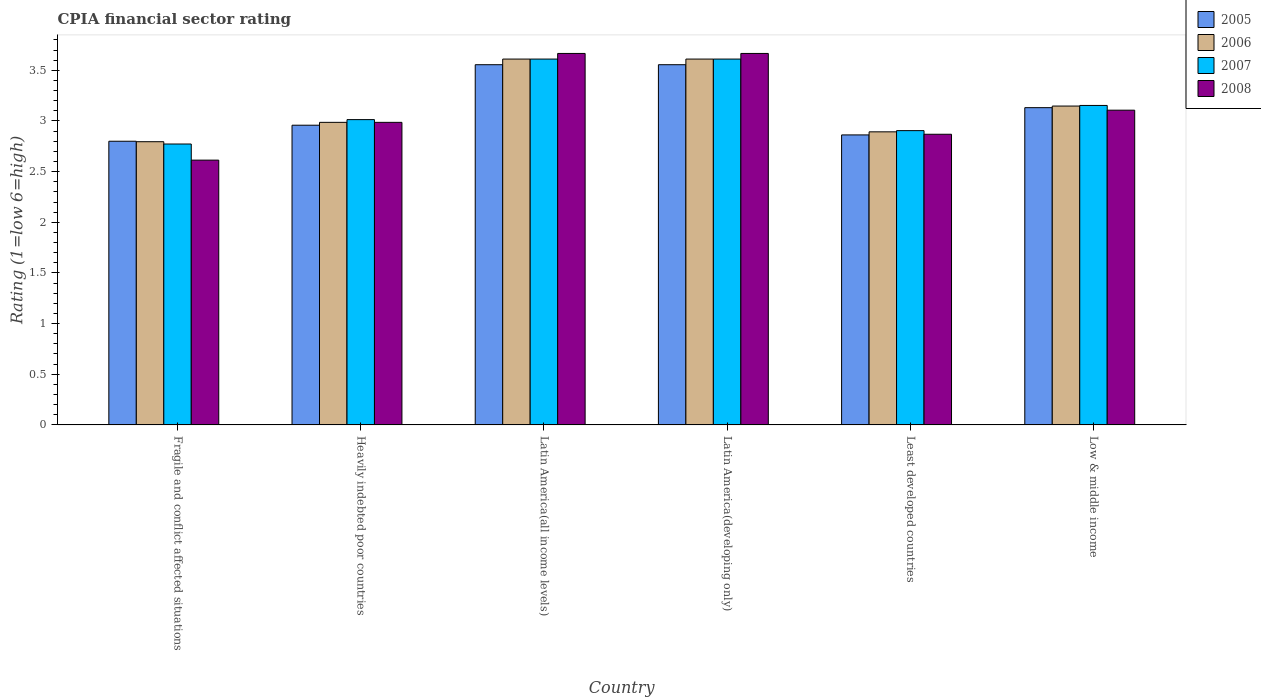How many different coloured bars are there?
Ensure brevity in your answer.  4. How many groups of bars are there?
Offer a very short reply. 6. Are the number of bars per tick equal to the number of legend labels?
Ensure brevity in your answer.  Yes. How many bars are there on the 2nd tick from the right?
Provide a short and direct response. 4. What is the label of the 1st group of bars from the left?
Give a very brief answer. Fragile and conflict affected situations. In how many cases, is the number of bars for a given country not equal to the number of legend labels?
Provide a succinct answer. 0. What is the CPIA rating in 2005 in Least developed countries?
Your response must be concise. 2.86. Across all countries, what is the maximum CPIA rating in 2006?
Give a very brief answer. 3.61. In which country was the CPIA rating in 2008 maximum?
Keep it short and to the point. Latin America(all income levels). In which country was the CPIA rating in 2005 minimum?
Keep it short and to the point. Fragile and conflict affected situations. What is the total CPIA rating in 2005 in the graph?
Your answer should be compact. 18.86. What is the difference between the CPIA rating in 2007 in Latin America(developing only) and that in Low & middle income?
Make the answer very short. 0.46. What is the difference between the CPIA rating in 2006 in Latin America(developing only) and the CPIA rating in 2005 in Fragile and conflict affected situations?
Provide a succinct answer. 0.81. What is the average CPIA rating in 2005 per country?
Your answer should be very brief. 3.14. What is the ratio of the CPIA rating in 2005 in Heavily indebted poor countries to that in Latin America(all income levels)?
Provide a succinct answer. 0.83. Is the CPIA rating in 2005 in Least developed countries less than that in Low & middle income?
Provide a short and direct response. Yes. What is the difference between the highest and the second highest CPIA rating in 2005?
Provide a succinct answer. -0.42. What is the difference between the highest and the lowest CPIA rating in 2006?
Ensure brevity in your answer.  0.82. In how many countries, is the CPIA rating in 2006 greater than the average CPIA rating in 2006 taken over all countries?
Make the answer very short. 2. Is the sum of the CPIA rating in 2008 in Heavily indebted poor countries and Latin America(developing only) greater than the maximum CPIA rating in 2006 across all countries?
Your answer should be compact. Yes. What does the 4th bar from the left in Heavily indebted poor countries represents?
Keep it short and to the point. 2008. What does the 2nd bar from the right in Heavily indebted poor countries represents?
Provide a succinct answer. 2007. How many countries are there in the graph?
Offer a terse response. 6. What is the difference between two consecutive major ticks on the Y-axis?
Your answer should be compact. 0.5. Are the values on the major ticks of Y-axis written in scientific E-notation?
Offer a very short reply. No. Does the graph contain grids?
Your answer should be very brief. No. How many legend labels are there?
Your answer should be compact. 4. What is the title of the graph?
Ensure brevity in your answer.  CPIA financial sector rating. Does "2013" appear as one of the legend labels in the graph?
Keep it short and to the point. No. What is the label or title of the X-axis?
Give a very brief answer. Country. What is the label or title of the Y-axis?
Provide a succinct answer. Rating (1=low 6=high). What is the Rating (1=low 6=high) of 2005 in Fragile and conflict affected situations?
Your answer should be very brief. 2.8. What is the Rating (1=low 6=high) in 2006 in Fragile and conflict affected situations?
Offer a terse response. 2.8. What is the Rating (1=low 6=high) of 2007 in Fragile and conflict affected situations?
Offer a terse response. 2.77. What is the Rating (1=low 6=high) of 2008 in Fragile and conflict affected situations?
Give a very brief answer. 2.61. What is the Rating (1=low 6=high) of 2005 in Heavily indebted poor countries?
Give a very brief answer. 2.96. What is the Rating (1=low 6=high) in 2006 in Heavily indebted poor countries?
Your answer should be very brief. 2.99. What is the Rating (1=low 6=high) in 2007 in Heavily indebted poor countries?
Your answer should be compact. 3.01. What is the Rating (1=low 6=high) of 2008 in Heavily indebted poor countries?
Your answer should be compact. 2.99. What is the Rating (1=low 6=high) of 2005 in Latin America(all income levels)?
Your response must be concise. 3.56. What is the Rating (1=low 6=high) in 2006 in Latin America(all income levels)?
Ensure brevity in your answer.  3.61. What is the Rating (1=low 6=high) in 2007 in Latin America(all income levels)?
Offer a terse response. 3.61. What is the Rating (1=low 6=high) of 2008 in Latin America(all income levels)?
Your response must be concise. 3.67. What is the Rating (1=low 6=high) in 2005 in Latin America(developing only)?
Offer a terse response. 3.56. What is the Rating (1=low 6=high) of 2006 in Latin America(developing only)?
Make the answer very short. 3.61. What is the Rating (1=low 6=high) in 2007 in Latin America(developing only)?
Your answer should be compact. 3.61. What is the Rating (1=low 6=high) in 2008 in Latin America(developing only)?
Offer a terse response. 3.67. What is the Rating (1=low 6=high) in 2005 in Least developed countries?
Your answer should be very brief. 2.86. What is the Rating (1=low 6=high) of 2006 in Least developed countries?
Offer a very short reply. 2.89. What is the Rating (1=low 6=high) in 2007 in Least developed countries?
Keep it short and to the point. 2.9. What is the Rating (1=low 6=high) in 2008 in Least developed countries?
Your response must be concise. 2.87. What is the Rating (1=low 6=high) of 2005 in Low & middle income?
Your answer should be compact. 3.13. What is the Rating (1=low 6=high) of 2006 in Low & middle income?
Offer a very short reply. 3.15. What is the Rating (1=low 6=high) in 2007 in Low & middle income?
Offer a very short reply. 3.15. What is the Rating (1=low 6=high) in 2008 in Low & middle income?
Make the answer very short. 3.11. Across all countries, what is the maximum Rating (1=low 6=high) of 2005?
Offer a terse response. 3.56. Across all countries, what is the maximum Rating (1=low 6=high) in 2006?
Give a very brief answer. 3.61. Across all countries, what is the maximum Rating (1=low 6=high) in 2007?
Your response must be concise. 3.61. Across all countries, what is the maximum Rating (1=low 6=high) of 2008?
Give a very brief answer. 3.67. Across all countries, what is the minimum Rating (1=low 6=high) of 2005?
Keep it short and to the point. 2.8. Across all countries, what is the minimum Rating (1=low 6=high) in 2006?
Ensure brevity in your answer.  2.8. Across all countries, what is the minimum Rating (1=low 6=high) in 2007?
Offer a terse response. 2.77. Across all countries, what is the minimum Rating (1=low 6=high) in 2008?
Provide a succinct answer. 2.61. What is the total Rating (1=low 6=high) in 2005 in the graph?
Ensure brevity in your answer.  18.86. What is the total Rating (1=low 6=high) in 2006 in the graph?
Provide a succinct answer. 19.04. What is the total Rating (1=low 6=high) of 2007 in the graph?
Your response must be concise. 19.07. What is the total Rating (1=low 6=high) of 2008 in the graph?
Provide a short and direct response. 18.91. What is the difference between the Rating (1=low 6=high) in 2005 in Fragile and conflict affected situations and that in Heavily indebted poor countries?
Make the answer very short. -0.16. What is the difference between the Rating (1=low 6=high) of 2006 in Fragile and conflict affected situations and that in Heavily indebted poor countries?
Offer a terse response. -0.19. What is the difference between the Rating (1=low 6=high) of 2007 in Fragile and conflict affected situations and that in Heavily indebted poor countries?
Make the answer very short. -0.24. What is the difference between the Rating (1=low 6=high) of 2008 in Fragile and conflict affected situations and that in Heavily indebted poor countries?
Provide a succinct answer. -0.37. What is the difference between the Rating (1=low 6=high) of 2005 in Fragile and conflict affected situations and that in Latin America(all income levels)?
Offer a very short reply. -0.76. What is the difference between the Rating (1=low 6=high) in 2006 in Fragile and conflict affected situations and that in Latin America(all income levels)?
Your answer should be very brief. -0.82. What is the difference between the Rating (1=low 6=high) in 2007 in Fragile and conflict affected situations and that in Latin America(all income levels)?
Provide a succinct answer. -0.84. What is the difference between the Rating (1=low 6=high) in 2008 in Fragile and conflict affected situations and that in Latin America(all income levels)?
Ensure brevity in your answer.  -1.05. What is the difference between the Rating (1=low 6=high) in 2005 in Fragile and conflict affected situations and that in Latin America(developing only)?
Offer a terse response. -0.76. What is the difference between the Rating (1=low 6=high) in 2006 in Fragile and conflict affected situations and that in Latin America(developing only)?
Keep it short and to the point. -0.82. What is the difference between the Rating (1=low 6=high) in 2007 in Fragile and conflict affected situations and that in Latin America(developing only)?
Your answer should be compact. -0.84. What is the difference between the Rating (1=low 6=high) of 2008 in Fragile and conflict affected situations and that in Latin America(developing only)?
Provide a short and direct response. -1.05. What is the difference between the Rating (1=low 6=high) of 2005 in Fragile and conflict affected situations and that in Least developed countries?
Offer a terse response. -0.06. What is the difference between the Rating (1=low 6=high) in 2006 in Fragile and conflict affected situations and that in Least developed countries?
Provide a short and direct response. -0.1. What is the difference between the Rating (1=low 6=high) of 2007 in Fragile and conflict affected situations and that in Least developed countries?
Make the answer very short. -0.13. What is the difference between the Rating (1=low 6=high) in 2008 in Fragile and conflict affected situations and that in Least developed countries?
Offer a very short reply. -0.26. What is the difference between the Rating (1=low 6=high) in 2005 in Fragile and conflict affected situations and that in Low & middle income?
Your response must be concise. -0.33. What is the difference between the Rating (1=low 6=high) in 2006 in Fragile and conflict affected situations and that in Low & middle income?
Provide a succinct answer. -0.35. What is the difference between the Rating (1=low 6=high) in 2007 in Fragile and conflict affected situations and that in Low & middle income?
Ensure brevity in your answer.  -0.38. What is the difference between the Rating (1=low 6=high) of 2008 in Fragile and conflict affected situations and that in Low & middle income?
Keep it short and to the point. -0.49. What is the difference between the Rating (1=low 6=high) in 2005 in Heavily indebted poor countries and that in Latin America(all income levels)?
Offer a very short reply. -0.6. What is the difference between the Rating (1=low 6=high) in 2006 in Heavily indebted poor countries and that in Latin America(all income levels)?
Offer a terse response. -0.62. What is the difference between the Rating (1=low 6=high) of 2007 in Heavily indebted poor countries and that in Latin America(all income levels)?
Offer a very short reply. -0.6. What is the difference between the Rating (1=low 6=high) in 2008 in Heavily indebted poor countries and that in Latin America(all income levels)?
Provide a short and direct response. -0.68. What is the difference between the Rating (1=low 6=high) in 2005 in Heavily indebted poor countries and that in Latin America(developing only)?
Ensure brevity in your answer.  -0.6. What is the difference between the Rating (1=low 6=high) in 2006 in Heavily indebted poor countries and that in Latin America(developing only)?
Provide a succinct answer. -0.62. What is the difference between the Rating (1=low 6=high) of 2007 in Heavily indebted poor countries and that in Latin America(developing only)?
Offer a terse response. -0.6. What is the difference between the Rating (1=low 6=high) in 2008 in Heavily indebted poor countries and that in Latin America(developing only)?
Provide a short and direct response. -0.68. What is the difference between the Rating (1=low 6=high) in 2005 in Heavily indebted poor countries and that in Least developed countries?
Your answer should be very brief. 0.1. What is the difference between the Rating (1=low 6=high) of 2006 in Heavily indebted poor countries and that in Least developed countries?
Offer a terse response. 0.09. What is the difference between the Rating (1=low 6=high) of 2007 in Heavily indebted poor countries and that in Least developed countries?
Keep it short and to the point. 0.11. What is the difference between the Rating (1=low 6=high) in 2008 in Heavily indebted poor countries and that in Least developed countries?
Keep it short and to the point. 0.12. What is the difference between the Rating (1=low 6=high) of 2005 in Heavily indebted poor countries and that in Low & middle income?
Give a very brief answer. -0.17. What is the difference between the Rating (1=low 6=high) in 2006 in Heavily indebted poor countries and that in Low & middle income?
Your answer should be very brief. -0.16. What is the difference between the Rating (1=low 6=high) of 2007 in Heavily indebted poor countries and that in Low & middle income?
Provide a short and direct response. -0.14. What is the difference between the Rating (1=low 6=high) in 2008 in Heavily indebted poor countries and that in Low & middle income?
Provide a succinct answer. -0.12. What is the difference between the Rating (1=low 6=high) in 2005 in Latin America(all income levels) and that in Latin America(developing only)?
Make the answer very short. 0. What is the difference between the Rating (1=low 6=high) in 2007 in Latin America(all income levels) and that in Latin America(developing only)?
Offer a very short reply. 0. What is the difference between the Rating (1=low 6=high) in 2005 in Latin America(all income levels) and that in Least developed countries?
Provide a short and direct response. 0.69. What is the difference between the Rating (1=low 6=high) in 2006 in Latin America(all income levels) and that in Least developed countries?
Your answer should be very brief. 0.72. What is the difference between the Rating (1=low 6=high) in 2007 in Latin America(all income levels) and that in Least developed countries?
Give a very brief answer. 0.71. What is the difference between the Rating (1=low 6=high) of 2008 in Latin America(all income levels) and that in Least developed countries?
Ensure brevity in your answer.  0.8. What is the difference between the Rating (1=low 6=high) in 2005 in Latin America(all income levels) and that in Low & middle income?
Keep it short and to the point. 0.42. What is the difference between the Rating (1=low 6=high) in 2006 in Latin America(all income levels) and that in Low & middle income?
Make the answer very short. 0.46. What is the difference between the Rating (1=low 6=high) in 2007 in Latin America(all income levels) and that in Low & middle income?
Ensure brevity in your answer.  0.46. What is the difference between the Rating (1=low 6=high) of 2008 in Latin America(all income levels) and that in Low & middle income?
Provide a succinct answer. 0.56. What is the difference between the Rating (1=low 6=high) of 2005 in Latin America(developing only) and that in Least developed countries?
Offer a very short reply. 0.69. What is the difference between the Rating (1=low 6=high) in 2006 in Latin America(developing only) and that in Least developed countries?
Give a very brief answer. 0.72. What is the difference between the Rating (1=low 6=high) of 2007 in Latin America(developing only) and that in Least developed countries?
Offer a very short reply. 0.71. What is the difference between the Rating (1=low 6=high) of 2008 in Latin America(developing only) and that in Least developed countries?
Ensure brevity in your answer.  0.8. What is the difference between the Rating (1=low 6=high) of 2005 in Latin America(developing only) and that in Low & middle income?
Offer a very short reply. 0.42. What is the difference between the Rating (1=low 6=high) in 2006 in Latin America(developing only) and that in Low & middle income?
Your response must be concise. 0.46. What is the difference between the Rating (1=low 6=high) of 2007 in Latin America(developing only) and that in Low & middle income?
Your answer should be compact. 0.46. What is the difference between the Rating (1=low 6=high) in 2008 in Latin America(developing only) and that in Low & middle income?
Provide a short and direct response. 0.56. What is the difference between the Rating (1=low 6=high) in 2005 in Least developed countries and that in Low & middle income?
Ensure brevity in your answer.  -0.27. What is the difference between the Rating (1=low 6=high) in 2006 in Least developed countries and that in Low & middle income?
Give a very brief answer. -0.25. What is the difference between the Rating (1=low 6=high) of 2007 in Least developed countries and that in Low & middle income?
Make the answer very short. -0.25. What is the difference between the Rating (1=low 6=high) of 2008 in Least developed countries and that in Low & middle income?
Give a very brief answer. -0.24. What is the difference between the Rating (1=low 6=high) of 2005 in Fragile and conflict affected situations and the Rating (1=low 6=high) of 2006 in Heavily indebted poor countries?
Ensure brevity in your answer.  -0.19. What is the difference between the Rating (1=low 6=high) in 2005 in Fragile and conflict affected situations and the Rating (1=low 6=high) in 2007 in Heavily indebted poor countries?
Ensure brevity in your answer.  -0.21. What is the difference between the Rating (1=low 6=high) of 2005 in Fragile and conflict affected situations and the Rating (1=low 6=high) of 2008 in Heavily indebted poor countries?
Provide a succinct answer. -0.19. What is the difference between the Rating (1=low 6=high) in 2006 in Fragile and conflict affected situations and the Rating (1=low 6=high) in 2007 in Heavily indebted poor countries?
Offer a terse response. -0.22. What is the difference between the Rating (1=low 6=high) in 2006 in Fragile and conflict affected situations and the Rating (1=low 6=high) in 2008 in Heavily indebted poor countries?
Offer a very short reply. -0.19. What is the difference between the Rating (1=low 6=high) of 2007 in Fragile and conflict affected situations and the Rating (1=low 6=high) of 2008 in Heavily indebted poor countries?
Provide a short and direct response. -0.21. What is the difference between the Rating (1=low 6=high) in 2005 in Fragile and conflict affected situations and the Rating (1=low 6=high) in 2006 in Latin America(all income levels)?
Keep it short and to the point. -0.81. What is the difference between the Rating (1=low 6=high) in 2005 in Fragile and conflict affected situations and the Rating (1=low 6=high) in 2007 in Latin America(all income levels)?
Give a very brief answer. -0.81. What is the difference between the Rating (1=low 6=high) of 2005 in Fragile and conflict affected situations and the Rating (1=low 6=high) of 2008 in Latin America(all income levels)?
Offer a very short reply. -0.87. What is the difference between the Rating (1=low 6=high) in 2006 in Fragile and conflict affected situations and the Rating (1=low 6=high) in 2007 in Latin America(all income levels)?
Offer a very short reply. -0.82. What is the difference between the Rating (1=low 6=high) of 2006 in Fragile and conflict affected situations and the Rating (1=low 6=high) of 2008 in Latin America(all income levels)?
Keep it short and to the point. -0.87. What is the difference between the Rating (1=low 6=high) of 2007 in Fragile and conflict affected situations and the Rating (1=low 6=high) of 2008 in Latin America(all income levels)?
Make the answer very short. -0.89. What is the difference between the Rating (1=low 6=high) in 2005 in Fragile and conflict affected situations and the Rating (1=low 6=high) in 2006 in Latin America(developing only)?
Ensure brevity in your answer.  -0.81. What is the difference between the Rating (1=low 6=high) of 2005 in Fragile and conflict affected situations and the Rating (1=low 6=high) of 2007 in Latin America(developing only)?
Your answer should be very brief. -0.81. What is the difference between the Rating (1=low 6=high) in 2005 in Fragile and conflict affected situations and the Rating (1=low 6=high) in 2008 in Latin America(developing only)?
Make the answer very short. -0.87. What is the difference between the Rating (1=low 6=high) of 2006 in Fragile and conflict affected situations and the Rating (1=low 6=high) of 2007 in Latin America(developing only)?
Provide a short and direct response. -0.82. What is the difference between the Rating (1=low 6=high) of 2006 in Fragile and conflict affected situations and the Rating (1=low 6=high) of 2008 in Latin America(developing only)?
Your response must be concise. -0.87. What is the difference between the Rating (1=low 6=high) of 2007 in Fragile and conflict affected situations and the Rating (1=low 6=high) of 2008 in Latin America(developing only)?
Offer a terse response. -0.89. What is the difference between the Rating (1=low 6=high) of 2005 in Fragile and conflict affected situations and the Rating (1=low 6=high) of 2006 in Least developed countries?
Offer a terse response. -0.09. What is the difference between the Rating (1=low 6=high) in 2005 in Fragile and conflict affected situations and the Rating (1=low 6=high) in 2007 in Least developed countries?
Keep it short and to the point. -0.1. What is the difference between the Rating (1=low 6=high) of 2005 in Fragile and conflict affected situations and the Rating (1=low 6=high) of 2008 in Least developed countries?
Your answer should be compact. -0.07. What is the difference between the Rating (1=low 6=high) of 2006 in Fragile and conflict affected situations and the Rating (1=low 6=high) of 2007 in Least developed countries?
Your response must be concise. -0.11. What is the difference between the Rating (1=low 6=high) of 2006 in Fragile and conflict affected situations and the Rating (1=low 6=high) of 2008 in Least developed countries?
Your answer should be very brief. -0.07. What is the difference between the Rating (1=low 6=high) in 2007 in Fragile and conflict affected situations and the Rating (1=low 6=high) in 2008 in Least developed countries?
Offer a very short reply. -0.1. What is the difference between the Rating (1=low 6=high) of 2005 in Fragile and conflict affected situations and the Rating (1=low 6=high) of 2006 in Low & middle income?
Your answer should be very brief. -0.35. What is the difference between the Rating (1=low 6=high) in 2005 in Fragile and conflict affected situations and the Rating (1=low 6=high) in 2007 in Low & middle income?
Offer a terse response. -0.35. What is the difference between the Rating (1=low 6=high) in 2005 in Fragile and conflict affected situations and the Rating (1=low 6=high) in 2008 in Low & middle income?
Give a very brief answer. -0.31. What is the difference between the Rating (1=low 6=high) of 2006 in Fragile and conflict affected situations and the Rating (1=low 6=high) of 2007 in Low & middle income?
Offer a very short reply. -0.36. What is the difference between the Rating (1=low 6=high) in 2006 in Fragile and conflict affected situations and the Rating (1=low 6=high) in 2008 in Low & middle income?
Make the answer very short. -0.31. What is the difference between the Rating (1=low 6=high) of 2007 in Fragile and conflict affected situations and the Rating (1=low 6=high) of 2008 in Low & middle income?
Provide a short and direct response. -0.33. What is the difference between the Rating (1=low 6=high) in 2005 in Heavily indebted poor countries and the Rating (1=low 6=high) in 2006 in Latin America(all income levels)?
Your response must be concise. -0.65. What is the difference between the Rating (1=low 6=high) of 2005 in Heavily indebted poor countries and the Rating (1=low 6=high) of 2007 in Latin America(all income levels)?
Provide a succinct answer. -0.65. What is the difference between the Rating (1=low 6=high) in 2005 in Heavily indebted poor countries and the Rating (1=low 6=high) in 2008 in Latin America(all income levels)?
Your answer should be very brief. -0.71. What is the difference between the Rating (1=low 6=high) in 2006 in Heavily indebted poor countries and the Rating (1=low 6=high) in 2007 in Latin America(all income levels)?
Offer a very short reply. -0.62. What is the difference between the Rating (1=low 6=high) in 2006 in Heavily indebted poor countries and the Rating (1=low 6=high) in 2008 in Latin America(all income levels)?
Your response must be concise. -0.68. What is the difference between the Rating (1=low 6=high) in 2007 in Heavily indebted poor countries and the Rating (1=low 6=high) in 2008 in Latin America(all income levels)?
Give a very brief answer. -0.65. What is the difference between the Rating (1=low 6=high) of 2005 in Heavily indebted poor countries and the Rating (1=low 6=high) of 2006 in Latin America(developing only)?
Offer a very short reply. -0.65. What is the difference between the Rating (1=low 6=high) of 2005 in Heavily indebted poor countries and the Rating (1=low 6=high) of 2007 in Latin America(developing only)?
Ensure brevity in your answer.  -0.65. What is the difference between the Rating (1=low 6=high) of 2005 in Heavily indebted poor countries and the Rating (1=low 6=high) of 2008 in Latin America(developing only)?
Keep it short and to the point. -0.71. What is the difference between the Rating (1=low 6=high) in 2006 in Heavily indebted poor countries and the Rating (1=low 6=high) in 2007 in Latin America(developing only)?
Provide a short and direct response. -0.62. What is the difference between the Rating (1=low 6=high) of 2006 in Heavily indebted poor countries and the Rating (1=low 6=high) of 2008 in Latin America(developing only)?
Keep it short and to the point. -0.68. What is the difference between the Rating (1=low 6=high) in 2007 in Heavily indebted poor countries and the Rating (1=low 6=high) in 2008 in Latin America(developing only)?
Ensure brevity in your answer.  -0.65. What is the difference between the Rating (1=low 6=high) of 2005 in Heavily indebted poor countries and the Rating (1=low 6=high) of 2006 in Least developed countries?
Your answer should be compact. 0.07. What is the difference between the Rating (1=low 6=high) of 2005 in Heavily indebted poor countries and the Rating (1=low 6=high) of 2007 in Least developed countries?
Ensure brevity in your answer.  0.05. What is the difference between the Rating (1=low 6=high) in 2005 in Heavily indebted poor countries and the Rating (1=low 6=high) in 2008 in Least developed countries?
Provide a short and direct response. 0.09. What is the difference between the Rating (1=low 6=high) in 2006 in Heavily indebted poor countries and the Rating (1=low 6=high) in 2007 in Least developed countries?
Your answer should be very brief. 0.08. What is the difference between the Rating (1=low 6=high) in 2006 in Heavily indebted poor countries and the Rating (1=low 6=high) in 2008 in Least developed countries?
Offer a terse response. 0.12. What is the difference between the Rating (1=low 6=high) in 2007 in Heavily indebted poor countries and the Rating (1=low 6=high) in 2008 in Least developed countries?
Provide a short and direct response. 0.14. What is the difference between the Rating (1=low 6=high) of 2005 in Heavily indebted poor countries and the Rating (1=low 6=high) of 2006 in Low & middle income?
Your answer should be compact. -0.19. What is the difference between the Rating (1=low 6=high) in 2005 in Heavily indebted poor countries and the Rating (1=low 6=high) in 2007 in Low & middle income?
Your response must be concise. -0.2. What is the difference between the Rating (1=low 6=high) in 2005 in Heavily indebted poor countries and the Rating (1=low 6=high) in 2008 in Low & middle income?
Your answer should be very brief. -0.15. What is the difference between the Rating (1=low 6=high) of 2006 in Heavily indebted poor countries and the Rating (1=low 6=high) of 2007 in Low & middle income?
Keep it short and to the point. -0.17. What is the difference between the Rating (1=low 6=high) in 2006 in Heavily indebted poor countries and the Rating (1=low 6=high) in 2008 in Low & middle income?
Your answer should be compact. -0.12. What is the difference between the Rating (1=low 6=high) in 2007 in Heavily indebted poor countries and the Rating (1=low 6=high) in 2008 in Low & middle income?
Provide a succinct answer. -0.09. What is the difference between the Rating (1=low 6=high) of 2005 in Latin America(all income levels) and the Rating (1=low 6=high) of 2006 in Latin America(developing only)?
Your response must be concise. -0.06. What is the difference between the Rating (1=low 6=high) in 2005 in Latin America(all income levels) and the Rating (1=low 6=high) in 2007 in Latin America(developing only)?
Your response must be concise. -0.06. What is the difference between the Rating (1=low 6=high) in 2005 in Latin America(all income levels) and the Rating (1=low 6=high) in 2008 in Latin America(developing only)?
Ensure brevity in your answer.  -0.11. What is the difference between the Rating (1=low 6=high) in 2006 in Latin America(all income levels) and the Rating (1=low 6=high) in 2008 in Latin America(developing only)?
Make the answer very short. -0.06. What is the difference between the Rating (1=low 6=high) in 2007 in Latin America(all income levels) and the Rating (1=low 6=high) in 2008 in Latin America(developing only)?
Make the answer very short. -0.06. What is the difference between the Rating (1=low 6=high) in 2005 in Latin America(all income levels) and the Rating (1=low 6=high) in 2006 in Least developed countries?
Your answer should be compact. 0.66. What is the difference between the Rating (1=low 6=high) of 2005 in Latin America(all income levels) and the Rating (1=low 6=high) of 2007 in Least developed countries?
Keep it short and to the point. 0.65. What is the difference between the Rating (1=low 6=high) in 2005 in Latin America(all income levels) and the Rating (1=low 6=high) in 2008 in Least developed countries?
Keep it short and to the point. 0.69. What is the difference between the Rating (1=low 6=high) of 2006 in Latin America(all income levels) and the Rating (1=low 6=high) of 2007 in Least developed countries?
Keep it short and to the point. 0.71. What is the difference between the Rating (1=low 6=high) in 2006 in Latin America(all income levels) and the Rating (1=low 6=high) in 2008 in Least developed countries?
Ensure brevity in your answer.  0.74. What is the difference between the Rating (1=low 6=high) in 2007 in Latin America(all income levels) and the Rating (1=low 6=high) in 2008 in Least developed countries?
Give a very brief answer. 0.74. What is the difference between the Rating (1=low 6=high) in 2005 in Latin America(all income levels) and the Rating (1=low 6=high) in 2006 in Low & middle income?
Offer a terse response. 0.41. What is the difference between the Rating (1=low 6=high) of 2005 in Latin America(all income levels) and the Rating (1=low 6=high) of 2007 in Low & middle income?
Offer a very short reply. 0.4. What is the difference between the Rating (1=low 6=high) of 2005 in Latin America(all income levels) and the Rating (1=low 6=high) of 2008 in Low & middle income?
Offer a very short reply. 0.45. What is the difference between the Rating (1=low 6=high) in 2006 in Latin America(all income levels) and the Rating (1=low 6=high) in 2007 in Low & middle income?
Ensure brevity in your answer.  0.46. What is the difference between the Rating (1=low 6=high) in 2006 in Latin America(all income levels) and the Rating (1=low 6=high) in 2008 in Low & middle income?
Ensure brevity in your answer.  0.5. What is the difference between the Rating (1=low 6=high) in 2007 in Latin America(all income levels) and the Rating (1=low 6=high) in 2008 in Low & middle income?
Offer a very short reply. 0.5. What is the difference between the Rating (1=low 6=high) in 2005 in Latin America(developing only) and the Rating (1=low 6=high) in 2006 in Least developed countries?
Offer a very short reply. 0.66. What is the difference between the Rating (1=low 6=high) in 2005 in Latin America(developing only) and the Rating (1=low 6=high) in 2007 in Least developed countries?
Your answer should be compact. 0.65. What is the difference between the Rating (1=low 6=high) in 2005 in Latin America(developing only) and the Rating (1=low 6=high) in 2008 in Least developed countries?
Give a very brief answer. 0.69. What is the difference between the Rating (1=low 6=high) in 2006 in Latin America(developing only) and the Rating (1=low 6=high) in 2007 in Least developed countries?
Offer a terse response. 0.71. What is the difference between the Rating (1=low 6=high) of 2006 in Latin America(developing only) and the Rating (1=low 6=high) of 2008 in Least developed countries?
Offer a very short reply. 0.74. What is the difference between the Rating (1=low 6=high) of 2007 in Latin America(developing only) and the Rating (1=low 6=high) of 2008 in Least developed countries?
Make the answer very short. 0.74. What is the difference between the Rating (1=low 6=high) in 2005 in Latin America(developing only) and the Rating (1=low 6=high) in 2006 in Low & middle income?
Ensure brevity in your answer.  0.41. What is the difference between the Rating (1=low 6=high) in 2005 in Latin America(developing only) and the Rating (1=low 6=high) in 2007 in Low & middle income?
Keep it short and to the point. 0.4. What is the difference between the Rating (1=low 6=high) of 2005 in Latin America(developing only) and the Rating (1=low 6=high) of 2008 in Low & middle income?
Keep it short and to the point. 0.45. What is the difference between the Rating (1=low 6=high) of 2006 in Latin America(developing only) and the Rating (1=low 6=high) of 2007 in Low & middle income?
Make the answer very short. 0.46. What is the difference between the Rating (1=low 6=high) in 2006 in Latin America(developing only) and the Rating (1=low 6=high) in 2008 in Low & middle income?
Ensure brevity in your answer.  0.5. What is the difference between the Rating (1=low 6=high) in 2007 in Latin America(developing only) and the Rating (1=low 6=high) in 2008 in Low & middle income?
Ensure brevity in your answer.  0.5. What is the difference between the Rating (1=low 6=high) in 2005 in Least developed countries and the Rating (1=low 6=high) in 2006 in Low & middle income?
Offer a very short reply. -0.28. What is the difference between the Rating (1=low 6=high) of 2005 in Least developed countries and the Rating (1=low 6=high) of 2007 in Low & middle income?
Offer a terse response. -0.29. What is the difference between the Rating (1=low 6=high) in 2005 in Least developed countries and the Rating (1=low 6=high) in 2008 in Low & middle income?
Keep it short and to the point. -0.24. What is the difference between the Rating (1=low 6=high) of 2006 in Least developed countries and the Rating (1=low 6=high) of 2007 in Low & middle income?
Give a very brief answer. -0.26. What is the difference between the Rating (1=low 6=high) of 2006 in Least developed countries and the Rating (1=low 6=high) of 2008 in Low & middle income?
Offer a terse response. -0.21. What is the difference between the Rating (1=low 6=high) of 2007 in Least developed countries and the Rating (1=low 6=high) of 2008 in Low & middle income?
Keep it short and to the point. -0.2. What is the average Rating (1=low 6=high) of 2005 per country?
Your answer should be compact. 3.14. What is the average Rating (1=low 6=high) in 2006 per country?
Make the answer very short. 3.17. What is the average Rating (1=low 6=high) of 2007 per country?
Offer a terse response. 3.18. What is the average Rating (1=low 6=high) in 2008 per country?
Give a very brief answer. 3.15. What is the difference between the Rating (1=low 6=high) of 2005 and Rating (1=low 6=high) of 2006 in Fragile and conflict affected situations?
Your response must be concise. 0. What is the difference between the Rating (1=low 6=high) in 2005 and Rating (1=low 6=high) in 2007 in Fragile and conflict affected situations?
Your answer should be compact. 0.03. What is the difference between the Rating (1=low 6=high) of 2005 and Rating (1=low 6=high) of 2008 in Fragile and conflict affected situations?
Make the answer very short. 0.19. What is the difference between the Rating (1=low 6=high) of 2006 and Rating (1=low 6=high) of 2007 in Fragile and conflict affected situations?
Keep it short and to the point. 0.02. What is the difference between the Rating (1=low 6=high) of 2006 and Rating (1=low 6=high) of 2008 in Fragile and conflict affected situations?
Provide a short and direct response. 0.18. What is the difference between the Rating (1=low 6=high) of 2007 and Rating (1=low 6=high) of 2008 in Fragile and conflict affected situations?
Offer a very short reply. 0.16. What is the difference between the Rating (1=low 6=high) in 2005 and Rating (1=low 6=high) in 2006 in Heavily indebted poor countries?
Your answer should be compact. -0.03. What is the difference between the Rating (1=low 6=high) in 2005 and Rating (1=low 6=high) in 2007 in Heavily indebted poor countries?
Ensure brevity in your answer.  -0.06. What is the difference between the Rating (1=low 6=high) in 2005 and Rating (1=low 6=high) in 2008 in Heavily indebted poor countries?
Keep it short and to the point. -0.03. What is the difference between the Rating (1=low 6=high) of 2006 and Rating (1=low 6=high) of 2007 in Heavily indebted poor countries?
Offer a terse response. -0.03. What is the difference between the Rating (1=low 6=high) in 2007 and Rating (1=low 6=high) in 2008 in Heavily indebted poor countries?
Provide a succinct answer. 0.03. What is the difference between the Rating (1=low 6=high) of 2005 and Rating (1=low 6=high) of 2006 in Latin America(all income levels)?
Provide a succinct answer. -0.06. What is the difference between the Rating (1=low 6=high) in 2005 and Rating (1=low 6=high) in 2007 in Latin America(all income levels)?
Give a very brief answer. -0.06. What is the difference between the Rating (1=low 6=high) of 2005 and Rating (1=low 6=high) of 2008 in Latin America(all income levels)?
Offer a terse response. -0.11. What is the difference between the Rating (1=low 6=high) of 2006 and Rating (1=low 6=high) of 2008 in Latin America(all income levels)?
Your answer should be compact. -0.06. What is the difference between the Rating (1=low 6=high) of 2007 and Rating (1=low 6=high) of 2008 in Latin America(all income levels)?
Keep it short and to the point. -0.06. What is the difference between the Rating (1=low 6=high) in 2005 and Rating (1=low 6=high) in 2006 in Latin America(developing only)?
Provide a succinct answer. -0.06. What is the difference between the Rating (1=low 6=high) in 2005 and Rating (1=low 6=high) in 2007 in Latin America(developing only)?
Provide a short and direct response. -0.06. What is the difference between the Rating (1=low 6=high) of 2005 and Rating (1=low 6=high) of 2008 in Latin America(developing only)?
Provide a short and direct response. -0.11. What is the difference between the Rating (1=low 6=high) of 2006 and Rating (1=low 6=high) of 2008 in Latin America(developing only)?
Your answer should be very brief. -0.06. What is the difference between the Rating (1=low 6=high) of 2007 and Rating (1=low 6=high) of 2008 in Latin America(developing only)?
Your answer should be very brief. -0.06. What is the difference between the Rating (1=low 6=high) in 2005 and Rating (1=low 6=high) in 2006 in Least developed countries?
Your answer should be compact. -0.03. What is the difference between the Rating (1=low 6=high) in 2005 and Rating (1=low 6=high) in 2007 in Least developed countries?
Your response must be concise. -0.04. What is the difference between the Rating (1=low 6=high) in 2005 and Rating (1=low 6=high) in 2008 in Least developed countries?
Provide a succinct answer. -0.01. What is the difference between the Rating (1=low 6=high) in 2006 and Rating (1=low 6=high) in 2007 in Least developed countries?
Give a very brief answer. -0.01. What is the difference between the Rating (1=low 6=high) of 2006 and Rating (1=low 6=high) of 2008 in Least developed countries?
Your answer should be compact. 0.02. What is the difference between the Rating (1=low 6=high) in 2007 and Rating (1=low 6=high) in 2008 in Least developed countries?
Your response must be concise. 0.04. What is the difference between the Rating (1=low 6=high) of 2005 and Rating (1=low 6=high) of 2006 in Low & middle income?
Offer a terse response. -0.02. What is the difference between the Rating (1=low 6=high) in 2005 and Rating (1=low 6=high) in 2007 in Low & middle income?
Ensure brevity in your answer.  -0.02. What is the difference between the Rating (1=low 6=high) in 2005 and Rating (1=low 6=high) in 2008 in Low & middle income?
Provide a short and direct response. 0.02. What is the difference between the Rating (1=low 6=high) in 2006 and Rating (1=low 6=high) in 2007 in Low & middle income?
Keep it short and to the point. -0.01. What is the difference between the Rating (1=low 6=high) of 2006 and Rating (1=low 6=high) of 2008 in Low & middle income?
Your answer should be compact. 0.04. What is the difference between the Rating (1=low 6=high) of 2007 and Rating (1=low 6=high) of 2008 in Low & middle income?
Make the answer very short. 0.05. What is the ratio of the Rating (1=low 6=high) in 2005 in Fragile and conflict affected situations to that in Heavily indebted poor countries?
Provide a short and direct response. 0.95. What is the ratio of the Rating (1=low 6=high) in 2006 in Fragile and conflict affected situations to that in Heavily indebted poor countries?
Provide a short and direct response. 0.94. What is the ratio of the Rating (1=low 6=high) in 2007 in Fragile and conflict affected situations to that in Heavily indebted poor countries?
Your answer should be very brief. 0.92. What is the ratio of the Rating (1=low 6=high) of 2008 in Fragile and conflict affected situations to that in Heavily indebted poor countries?
Your answer should be compact. 0.88. What is the ratio of the Rating (1=low 6=high) of 2005 in Fragile and conflict affected situations to that in Latin America(all income levels)?
Your answer should be very brief. 0.79. What is the ratio of the Rating (1=low 6=high) of 2006 in Fragile and conflict affected situations to that in Latin America(all income levels)?
Ensure brevity in your answer.  0.77. What is the ratio of the Rating (1=low 6=high) of 2007 in Fragile and conflict affected situations to that in Latin America(all income levels)?
Offer a very short reply. 0.77. What is the ratio of the Rating (1=low 6=high) in 2008 in Fragile and conflict affected situations to that in Latin America(all income levels)?
Provide a short and direct response. 0.71. What is the ratio of the Rating (1=low 6=high) of 2005 in Fragile and conflict affected situations to that in Latin America(developing only)?
Your answer should be very brief. 0.79. What is the ratio of the Rating (1=low 6=high) in 2006 in Fragile and conflict affected situations to that in Latin America(developing only)?
Offer a terse response. 0.77. What is the ratio of the Rating (1=low 6=high) of 2007 in Fragile and conflict affected situations to that in Latin America(developing only)?
Ensure brevity in your answer.  0.77. What is the ratio of the Rating (1=low 6=high) in 2008 in Fragile and conflict affected situations to that in Latin America(developing only)?
Your answer should be very brief. 0.71. What is the ratio of the Rating (1=low 6=high) of 2005 in Fragile and conflict affected situations to that in Least developed countries?
Make the answer very short. 0.98. What is the ratio of the Rating (1=low 6=high) of 2006 in Fragile and conflict affected situations to that in Least developed countries?
Your answer should be very brief. 0.97. What is the ratio of the Rating (1=low 6=high) of 2007 in Fragile and conflict affected situations to that in Least developed countries?
Provide a succinct answer. 0.95. What is the ratio of the Rating (1=low 6=high) of 2008 in Fragile and conflict affected situations to that in Least developed countries?
Your answer should be very brief. 0.91. What is the ratio of the Rating (1=low 6=high) of 2005 in Fragile and conflict affected situations to that in Low & middle income?
Your response must be concise. 0.89. What is the ratio of the Rating (1=low 6=high) in 2006 in Fragile and conflict affected situations to that in Low & middle income?
Provide a short and direct response. 0.89. What is the ratio of the Rating (1=low 6=high) in 2007 in Fragile and conflict affected situations to that in Low & middle income?
Give a very brief answer. 0.88. What is the ratio of the Rating (1=low 6=high) in 2008 in Fragile and conflict affected situations to that in Low & middle income?
Your answer should be compact. 0.84. What is the ratio of the Rating (1=low 6=high) in 2005 in Heavily indebted poor countries to that in Latin America(all income levels)?
Provide a succinct answer. 0.83. What is the ratio of the Rating (1=low 6=high) in 2006 in Heavily indebted poor countries to that in Latin America(all income levels)?
Provide a short and direct response. 0.83. What is the ratio of the Rating (1=low 6=high) in 2007 in Heavily indebted poor countries to that in Latin America(all income levels)?
Provide a succinct answer. 0.83. What is the ratio of the Rating (1=low 6=high) in 2008 in Heavily indebted poor countries to that in Latin America(all income levels)?
Offer a terse response. 0.81. What is the ratio of the Rating (1=low 6=high) in 2005 in Heavily indebted poor countries to that in Latin America(developing only)?
Your answer should be compact. 0.83. What is the ratio of the Rating (1=low 6=high) in 2006 in Heavily indebted poor countries to that in Latin America(developing only)?
Your answer should be very brief. 0.83. What is the ratio of the Rating (1=low 6=high) of 2007 in Heavily indebted poor countries to that in Latin America(developing only)?
Your response must be concise. 0.83. What is the ratio of the Rating (1=low 6=high) of 2008 in Heavily indebted poor countries to that in Latin America(developing only)?
Offer a very short reply. 0.81. What is the ratio of the Rating (1=low 6=high) of 2005 in Heavily indebted poor countries to that in Least developed countries?
Your response must be concise. 1.03. What is the ratio of the Rating (1=low 6=high) of 2006 in Heavily indebted poor countries to that in Least developed countries?
Your response must be concise. 1.03. What is the ratio of the Rating (1=low 6=high) in 2007 in Heavily indebted poor countries to that in Least developed countries?
Your answer should be compact. 1.04. What is the ratio of the Rating (1=low 6=high) of 2008 in Heavily indebted poor countries to that in Least developed countries?
Provide a succinct answer. 1.04. What is the ratio of the Rating (1=low 6=high) of 2005 in Heavily indebted poor countries to that in Low & middle income?
Your answer should be very brief. 0.94. What is the ratio of the Rating (1=low 6=high) in 2006 in Heavily indebted poor countries to that in Low & middle income?
Your response must be concise. 0.95. What is the ratio of the Rating (1=low 6=high) in 2007 in Heavily indebted poor countries to that in Low & middle income?
Your answer should be compact. 0.96. What is the ratio of the Rating (1=low 6=high) of 2008 in Heavily indebted poor countries to that in Low & middle income?
Ensure brevity in your answer.  0.96. What is the ratio of the Rating (1=low 6=high) in 2006 in Latin America(all income levels) to that in Latin America(developing only)?
Give a very brief answer. 1. What is the ratio of the Rating (1=low 6=high) in 2005 in Latin America(all income levels) to that in Least developed countries?
Offer a very short reply. 1.24. What is the ratio of the Rating (1=low 6=high) in 2006 in Latin America(all income levels) to that in Least developed countries?
Your answer should be compact. 1.25. What is the ratio of the Rating (1=low 6=high) in 2007 in Latin America(all income levels) to that in Least developed countries?
Keep it short and to the point. 1.24. What is the ratio of the Rating (1=low 6=high) in 2008 in Latin America(all income levels) to that in Least developed countries?
Offer a terse response. 1.28. What is the ratio of the Rating (1=low 6=high) in 2005 in Latin America(all income levels) to that in Low & middle income?
Your answer should be very brief. 1.14. What is the ratio of the Rating (1=low 6=high) in 2006 in Latin America(all income levels) to that in Low & middle income?
Provide a short and direct response. 1.15. What is the ratio of the Rating (1=low 6=high) of 2007 in Latin America(all income levels) to that in Low & middle income?
Your answer should be compact. 1.15. What is the ratio of the Rating (1=low 6=high) of 2008 in Latin America(all income levels) to that in Low & middle income?
Your answer should be compact. 1.18. What is the ratio of the Rating (1=low 6=high) in 2005 in Latin America(developing only) to that in Least developed countries?
Ensure brevity in your answer.  1.24. What is the ratio of the Rating (1=low 6=high) in 2006 in Latin America(developing only) to that in Least developed countries?
Offer a very short reply. 1.25. What is the ratio of the Rating (1=low 6=high) in 2007 in Latin America(developing only) to that in Least developed countries?
Your answer should be very brief. 1.24. What is the ratio of the Rating (1=low 6=high) of 2008 in Latin America(developing only) to that in Least developed countries?
Make the answer very short. 1.28. What is the ratio of the Rating (1=low 6=high) of 2005 in Latin America(developing only) to that in Low & middle income?
Make the answer very short. 1.14. What is the ratio of the Rating (1=low 6=high) in 2006 in Latin America(developing only) to that in Low & middle income?
Offer a very short reply. 1.15. What is the ratio of the Rating (1=low 6=high) of 2007 in Latin America(developing only) to that in Low & middle income?
Provide a succinct answer. 1.15. What is the ratio of the Rating (1=low 6=high) of 2008 in Latin America(developing only) to that in Low & middle income?
Give a very brief answer. 1.18. What is the ratio of the Rating (1=low 6=high) of 2005 in Least developed countries to that in Low & middle income?
Your response must be concise. 0.91. What is the ratio of the Rating (1=low 6=high) in 2006 in Least developed countries to that in Low & middle income?
Your answer should be compact. 0.92. What is the ratio of the Rating (1=low 6=high) in 2007 in Least developed countries to that in Low & middle income?
Ensure brevity in your answer.  0.92. What is the ratio of the Rating (1=low 6=high) of 2008 in Least developed countries to that in Low & middle income?
Provide a succinct answer. 0.92. What is the difference between the highest and the second highest Rating (1=low 6=high) in 2006?
Ensure brevity in your answer.  0. What is the difference between the highest and the second highest Rating (1=low 6=high) in 2007?
Your response must be concise. 0. What is the difference between the highest and the second highest Rating (1=low 6=high) in 2008?
Provide a succinct answer. 0. What is the difference between the highest and the lowest Rating (1=low 6=high) in 2005?
Your response must be concise. 0.76. What is the difference between the highest and the lowest Rating (1=low 6=high) of 2006?
Ensure brevity in your answer.  0.82. What is the difference between the highest and the lowest Rating (1=low 6=high) of 2007?
Make the answer very short. 0.84. What is the difference between the highest and the lowest Rating (1=low 6=high) in 2008?
Your answer should be compact. 1.05. 